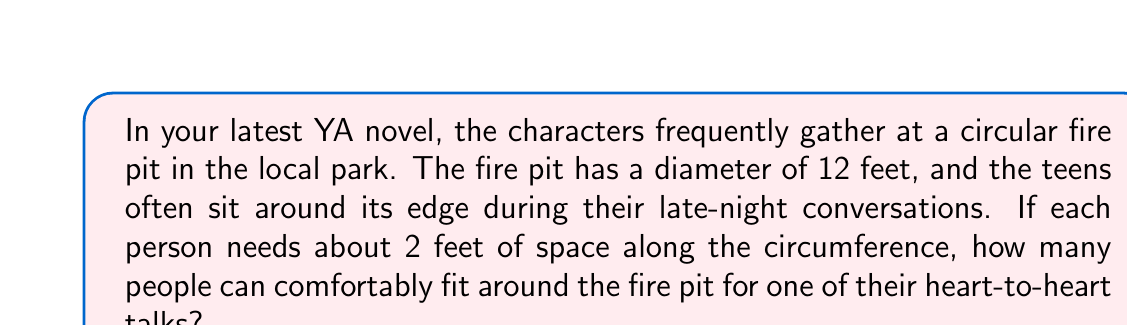Teach me how to tackle this problem. To solve this problem, we need to follow these steps:

1. Calculate the circumference of the fire pit:
   The formula for the circumference of a circle is $C = \pi d$, where $d$ is the diameter.
   
   $$C = \pi \times 12$$
   $$C = 37.699... \text{ feet}$$

2. Determine how many 2-foot spaces fit along the circumference:
   We can do this by dividing the circumference by 2 (the space each person needs).
   
   $$\text{Number of people} = \frac{C}{2} = \frac{37.699...}{2} = 18.849...$$

3. Round down to the nearest whole number:
   Since we can't have a fractional person, and we want to ensure everyone fits comfortably, we round down to 18.

[asy]
unitsize(10mm);
draw(circle((0,0),6));
draw((0,0)--(6,0),dashed);
label("12 ft", (3,0), S);
for(int i=0; i<18; ++i) {
  dot(6*dir(i*360/18));
}
[/asy]

This diagram illustrates the circular fire pit with 18 dots representing the people sitting around it.
Answer: 18 people can comfortably fit around the fire pit. 